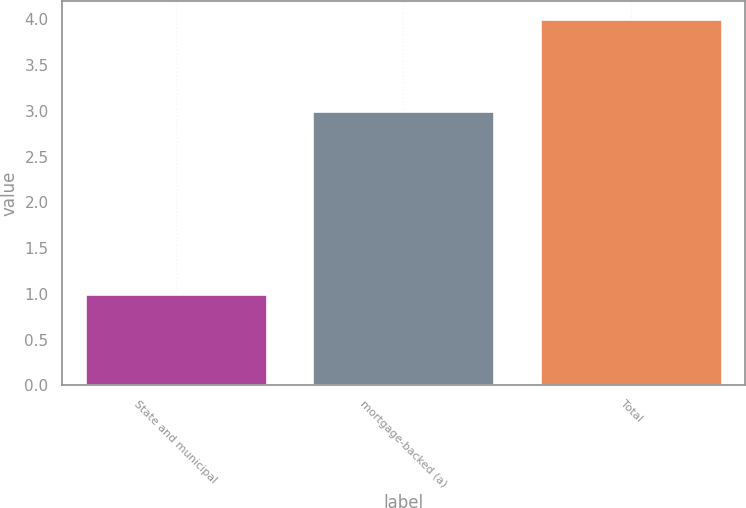Convert chart. <chart><loc_0><loc_0><loc_500><loc_500><bar_chart><fcel>State and municipal<fcel>mortgage-backed (a)<fcel>Total<nl><fcel>1<fcel>3<fcel>4<nl></chart> 